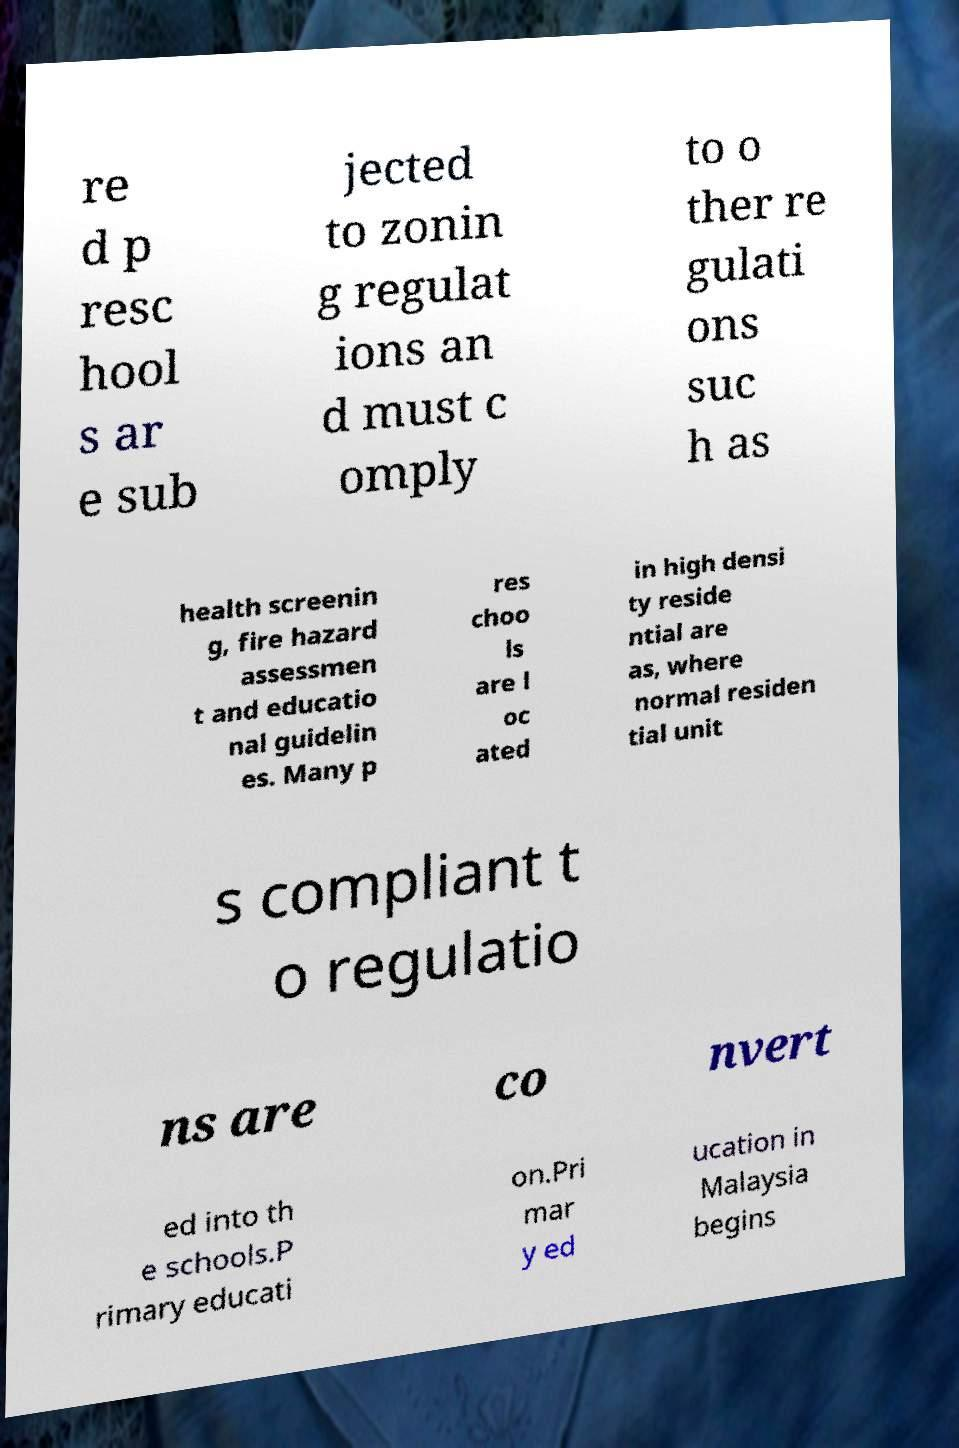For documentation purposes, I need the text within this image transcribed. Could you provide that? re d p resc hool s ar e sub jected to zonin g regulat ions an d must c omply to o ther re gulati ons suc h as health screenin g, fire hazard assessmen t and educatio nal guidelin es. Many p res choo ls are l oc ated in high densi ty reside ntial are as, where normal residen tial unit s compliant t o regulatio ns are co nvert ed into th e schools.P rimary educati on.Pri mar y ed ucation in Malaysia begins 